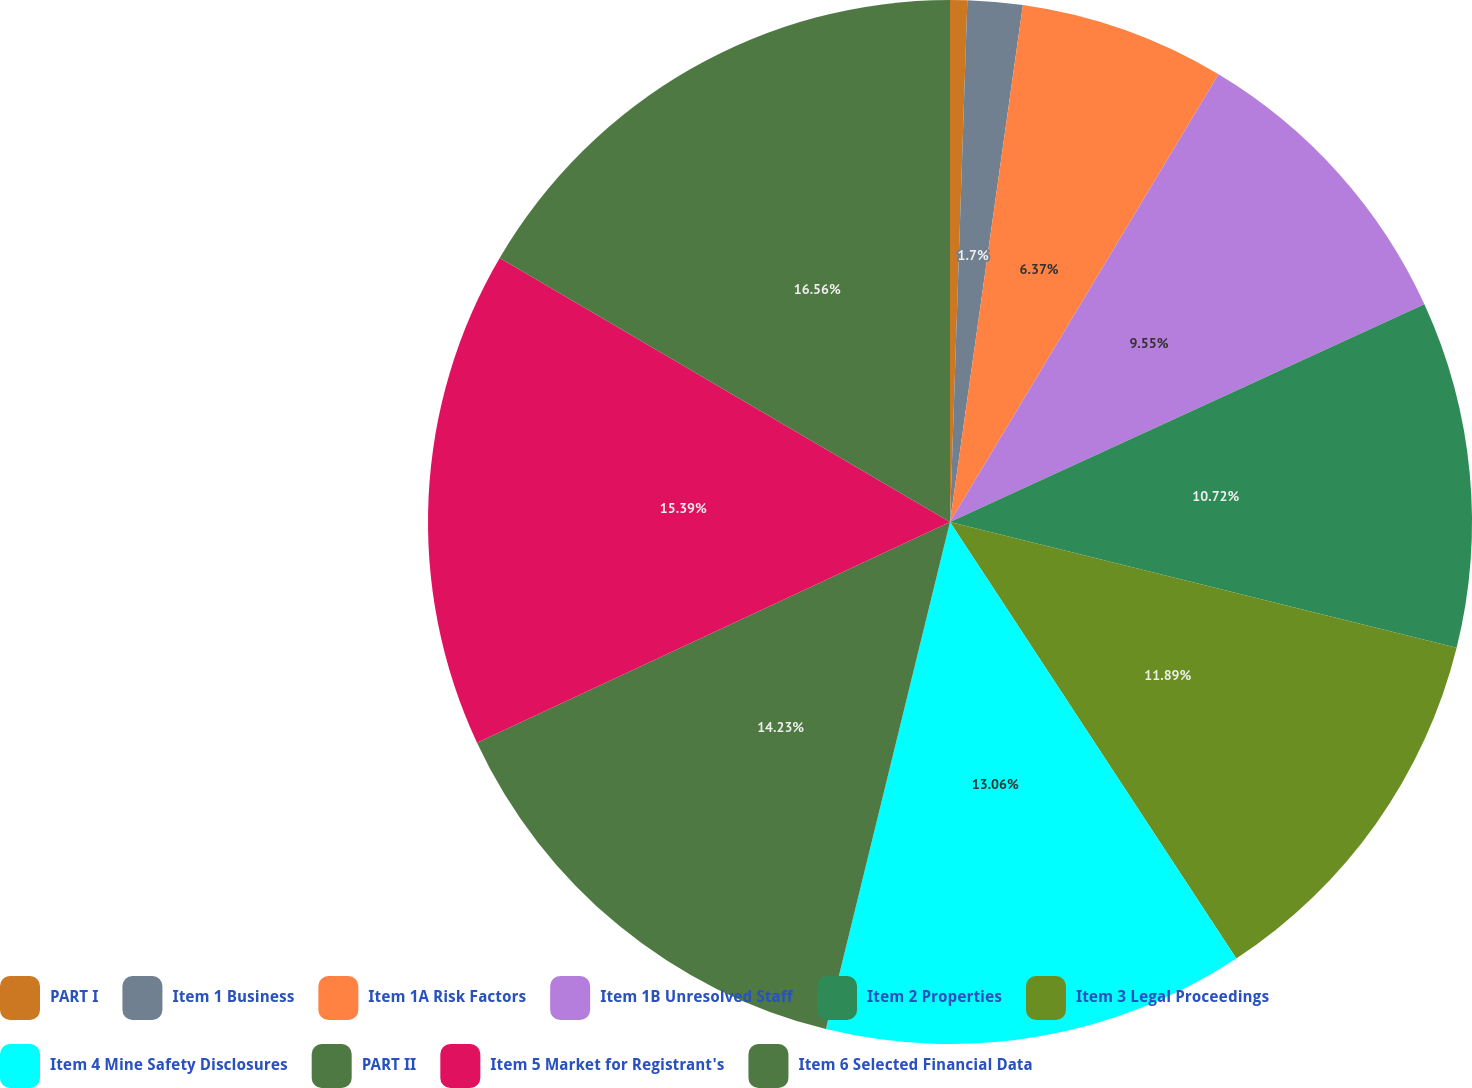Convert chart to OTSL. <chart><loc_0><loc_0><loc_500><loc_500><pie_chart><fcel>PART I<fcel>Item 1 Business<fcel>Item 1A Risk Factors<fcel>Item 1B Unresolved Staff<fcel>Item 2 Properties<fcel>Item 3 Legal Proceedings<fcel>Item 4 Mine Safety Disclosures<fcel>PART II<fcel>Item 5 Market for Registrant's<fcel>Item 6 Selected Financial Data<nl><fcel>0.53%<fcel>1.7%<fcel>6.37%<fcel>9.55%<fcel>10.72%<fcel>11.89%<fcel>13.06%<fcel>14.23%<fcel>15.39%<fcel>16.56%<nl></chart> 